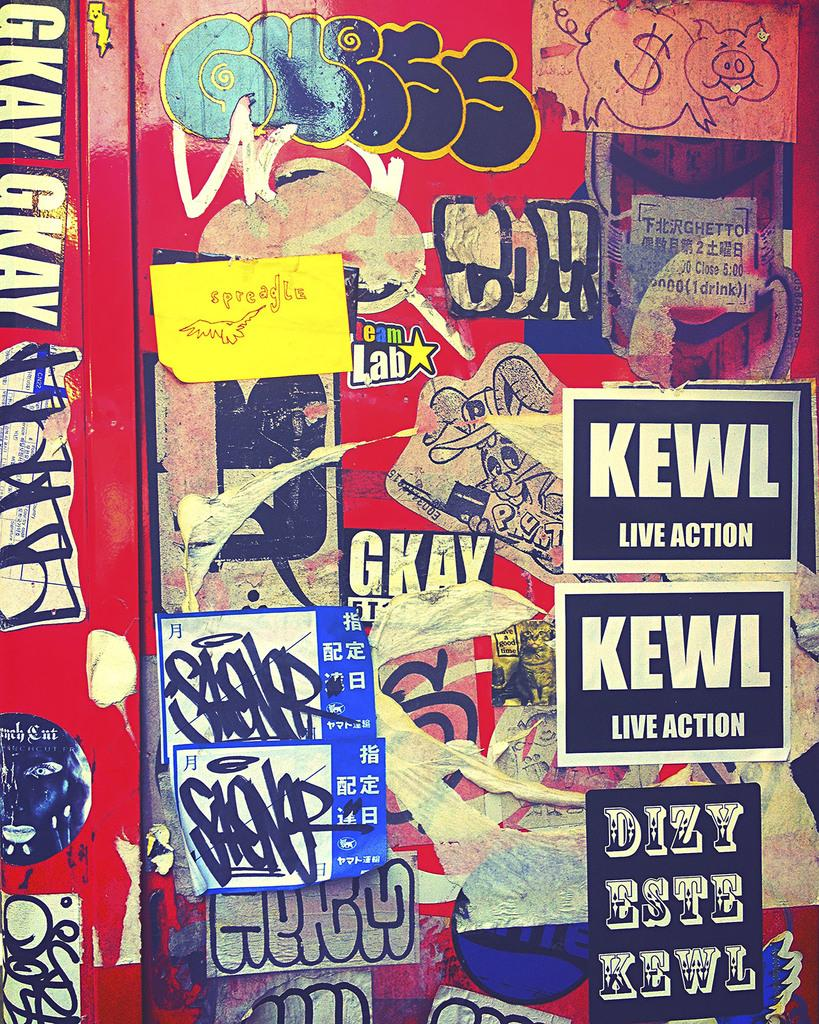<image>
Relay a brief, clear account of the picture shown. Stickers on a wall with one that says KEWL. 